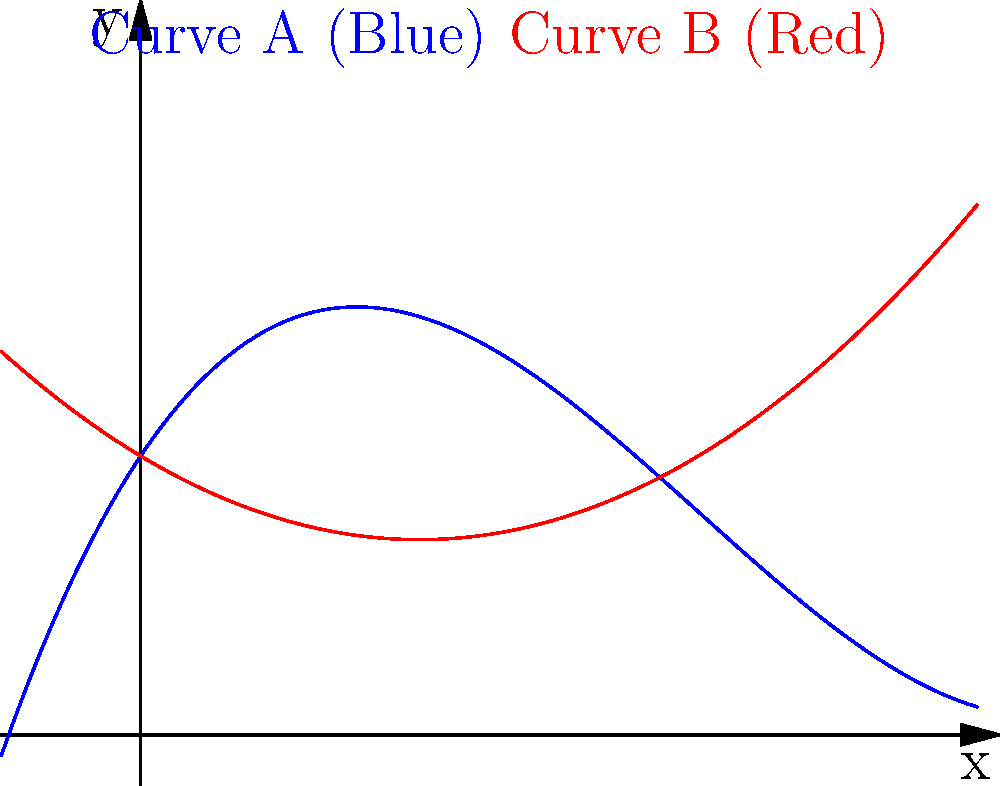As a navigator designing a smooth road curve, you're presented with two polynomial functions representing potential road paths:

Curve A (Blue): $f(x) = 0.05x^3 - 0.6x^2 + 1.5x + 2$
Curve B (Red): $g(x) = 0.15x^2 - 0.6x + 2$

Which curve would you recommend for a safer driving experience, and why? To determine the safer curve, we need to analyze the characteristics of both polynomials:

1. Degree of the polynomials:
   Curve A: Cubic (degree 3)
   Curve B: Quadratic (degree 2)

2. Rate of change:
   - The cubic function (Curve A) has a more gradual change in slope over its domain.
   - The quadratic function (Curve B) has a constant rate of change in its slope.

3. Smoothness:
   - Curve A appears smoother with a more gradual transition.
   - Curve B has a more abrupt change in direction.

4. Safety considerations:
   - Gradual changes in direction are safer for drivers, allowing for smoother steering adjustments.
   - Abrupt changes can lead to sudden steering corrections, potentially causing loss of control.

5. Long-term behavior:
   - Curve A's cubic nature allows for more flexibility in designing longer road segments.
   - Curve B's quadratic nature may lead to sharper turns over extended distances.

Conclusion:
Curve A (the cubic function) would be the safer choice. Its higher degree allows for a more gradual change in direction, providing a smoother driving experience and reducing the risk of sudden steering corrections.
Answer: Curve A (cubic function), due to its smoother and more gradual change in direction. 